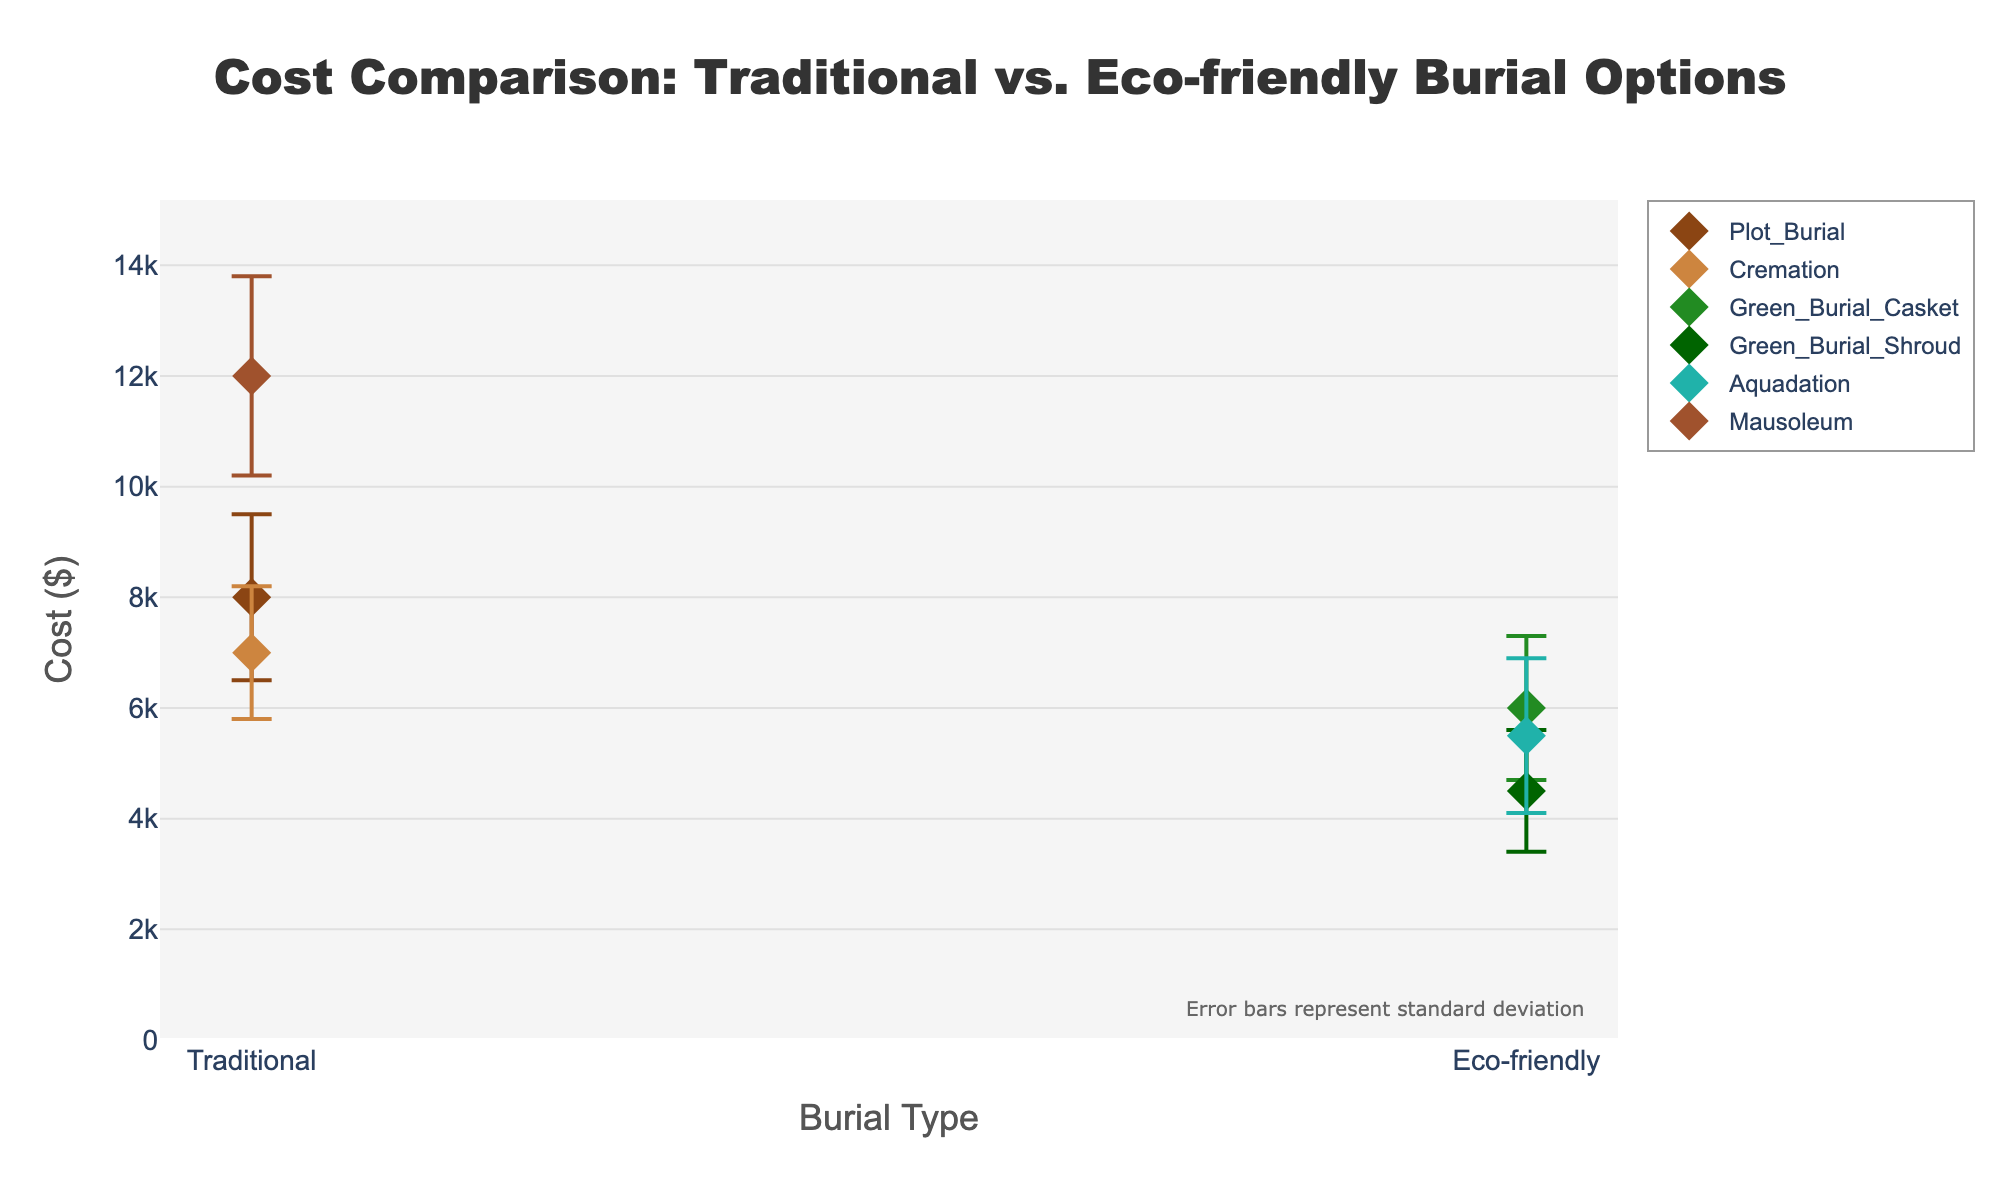What is the highest cost among the burial options shown? The highest cost is the largest value on the y-axis marked for a data point. The Mausoleum (Traditional) has the highest mean cost of $12,000.
Answer: $12,000 Which eco-friendly burial option has the lowest mean cost? By examining the mean costs of each eco-friendly option, the Green Burial Shroud has the lowest mean cost at $4,500.
Answer: $4,500 What does the title of the plot indicate? The title is "Cost Comparison: Traditional vs. Eco-friendly Burial Options," which indicates that the figure compares the costs of different types of burial options.
Answer: Cost Comparison: Traditional vs. Eco-friendly Burial Options How many burial options are categorized under Traditional? There are four data points on the x-axis labeled as "Traditional": Plot Burial, Cremation, Mausoleum, and Aquadation. However, Aquadation is an eco-friendly option, so the traditional options are Plot Burial, Cremation, and Mausoleum which means three.
Answer: 3 For the traditional burial options, which has the highest variability in cost? Look at the error bars (standard deviation) for each traditional option. The Mausoleum has the largest error bar with a standard deviation of $1,800.
Answer: Mausoleum Compare the mean cost of Green Burial Casket and Aquadation. Which one is higher? By comparing their mean costs on the y-axis, Green Burial Casket has a mean cost of $6,000, while Aquadation has a mean cost of $5,500. Therefore, Green Burial Casket is higher.
Answer: Green Burial Casket What is the range of costs for Traditional Plot Burial, including its error bars? The mean cost for Traditional Plot Burial is $8,000 with a standard deviation of $1,500. Therefore, the range of costs is $8,000 ± $1,500, or from $6,500 to $9,500.
Answer: $6,500 to $9,500 Which type of burial has the smallest error bar and what is its value? The error bars indicate the standard deviation, and the smallest error bar belongs to the Green Burial Shroud with a standard deviation of $1,100.
Answer: Green Burial Shroud, $1,100 Between Traditional Cremation and Eco-friendly Aquadation, which one is less costly and by how much? The mean cost for Traditional Cremation is $7,000, and for Eco-friendly Aquadation is $5,500. The cost difference is $7,000 - $5,500 = $1,500.
Answer: Eco-friendly Aquadation, $1,500 For the eco-friendly options, what is the mean cost averaging all their options? Calculate the average of mean costs for the three eco-friendly options: (6000 + 4500 + 5500) / 3. The sum is 16,000, and the average is 16,000 / 3 = $5,333.33.
Answer: $5,333.33 